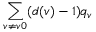Convert formula to latex. <formula><loc_0><loc_0><loc_500><loc_500>\sum _ { v \neq v 0 } ( d ( v ) - 1 ) q _ { v }</formula> 